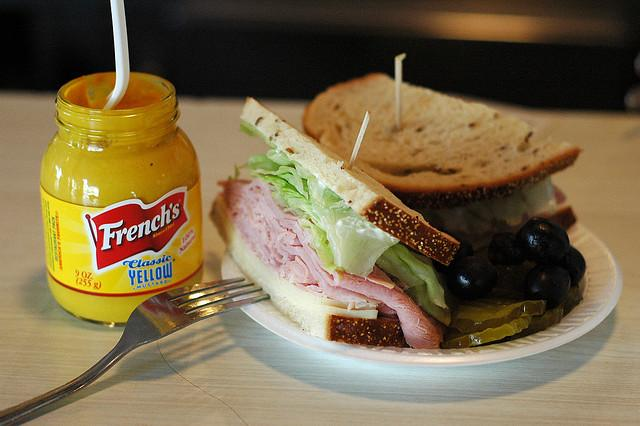Which one of these is a competitor of the company that make's the item in the jar? heinz 